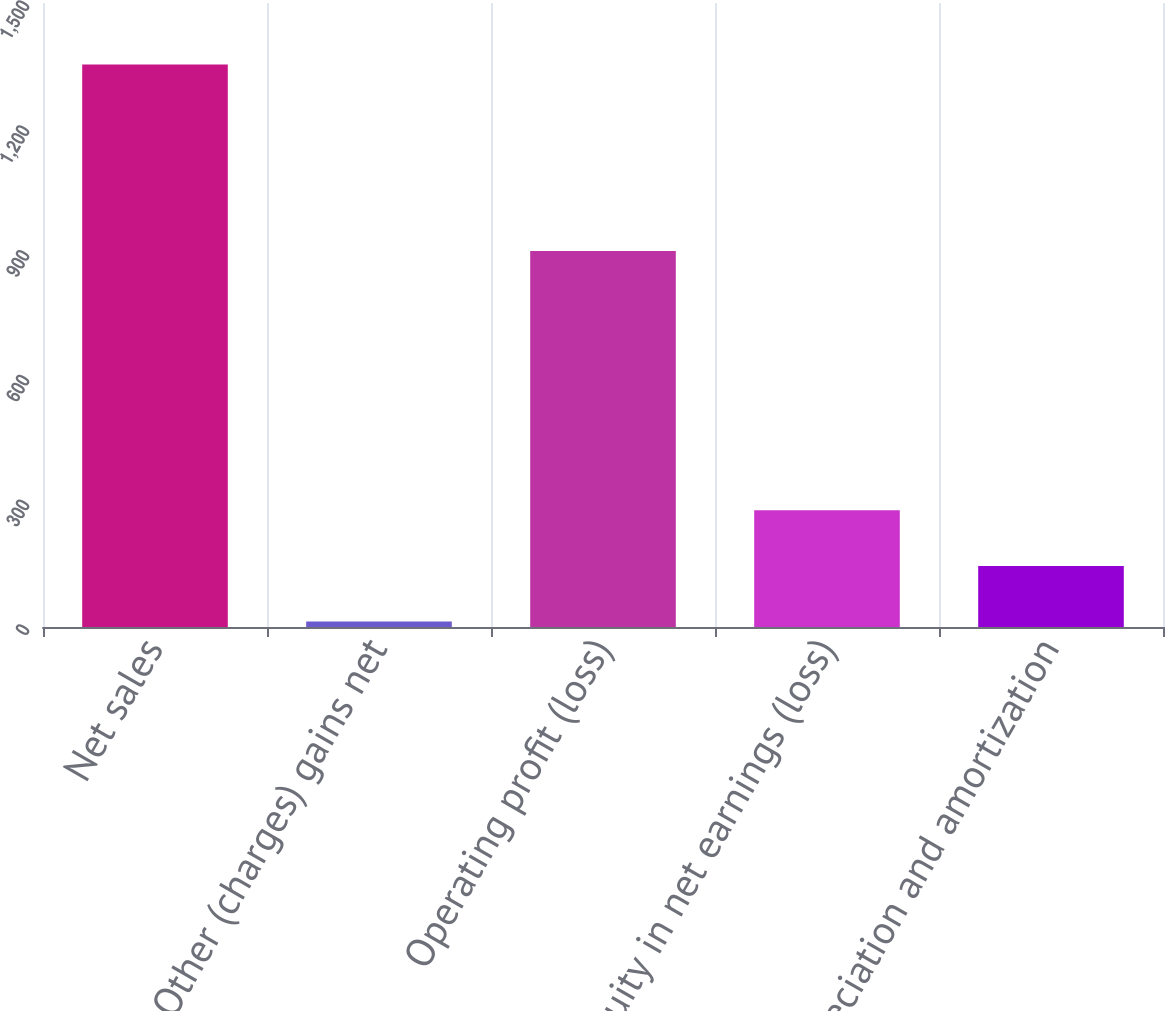Convert chart. <chart><loc_0><loc_0><loc_500><loc_500><bar_chart><fcel>Net sales<fcel>Other (charges) gains net<fcel>Operating profit (loss)<fcel>Equity in net earnings (loss)<fcel>Depreciation and amortization<nl><fcel>1352<fcel>13<fcel>904<fcel>280.8<fcel>146.9<nl></chart> 